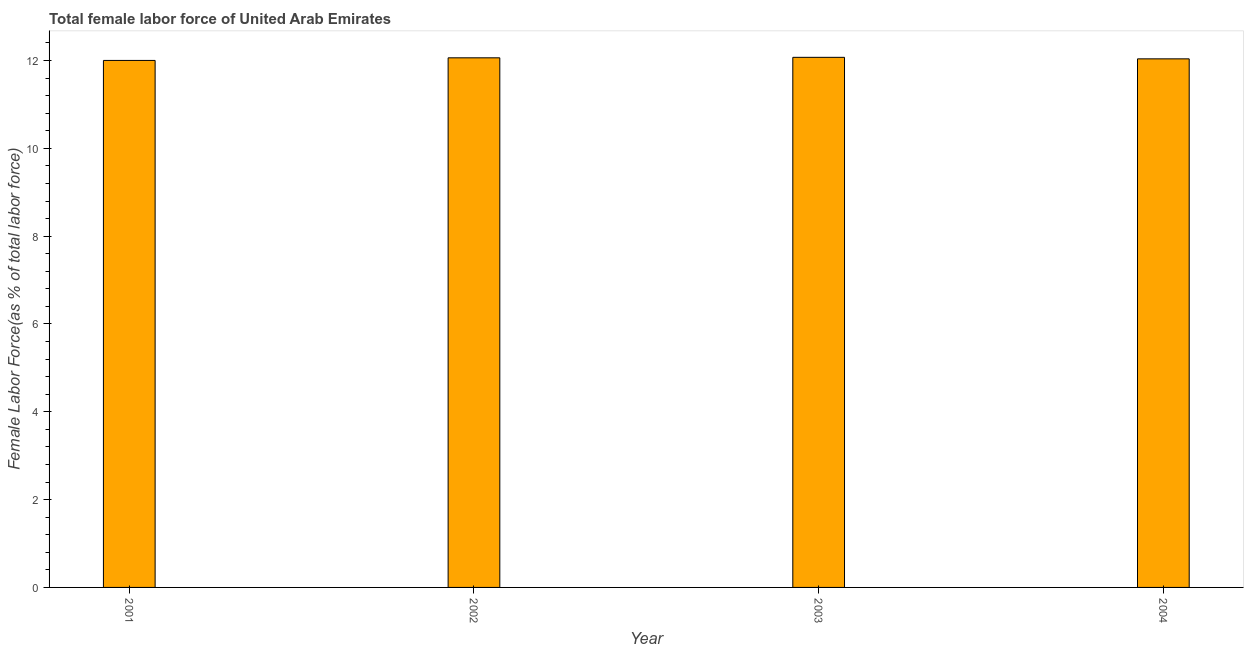What is the title of the graph?
Your response must be concise. Total female labor force of United Arab Emirates. What is the label or title of the Y-axis?
Your answer should be very brief. Female Labor Force(as % of total labor force). What is the total female labor force in 2003?
Make the answer very short. 12.07. Across all years, what is the maximum total female labor force?
Provide a succinct answer. 12.07. Across all years, what is the minimum total female labor force?
Ensure brevity in your answer.  12. In which year was the total female labor force maximum?
Give a very brief answer. 2003. What is the sum of the total female labor force?
Offer a very short reply. 48.18. What is the difference between the total female labor force in 2003 and 2004?
Keep it short and to the point. 0.04. What is the average total female labor force per year?
Offer a terse response. 12.04. What is the median total female labor force?
Provide a short and direct response. 12.05. Do a majority of the years between 2001 and 2004 (inclusive) have total female labor force greater than 8 %?
Offer a terse response. Yes. Is the difference between the total female labor force in 2001 and 2002 greater than the difference between any two years?
Your answer should be very brief. No. What is the difference between the highest and the second highest total female labor force?
Give a very brief answer. 0.01. What is the difference between the highest and the lowest total female labor force?
Provide a short and direct response. 0.07. In how many years, is the total female labor force greater than the average total female labor force taken over all years?
Provide a succinct answer. 2. Are all the bars in the graph horizontal?
Your answer should be compact. No. How many years are there in the graph?
Offer a very short reply. 4. Are the values on the major ticks of Y-axis written in scientific E-notation?
Provide a short and direct response. No. What is the Female Labor Force(as % of total labor force) of 2001?
Keep it short and to the point. 12. What is the Female Labor Force(as % of total labor force) in 2002?
Provide a short and direct response. 12.06. What is the Female Labor Force(as % of total labor force) in 2003?
Make the answer very short. 12.07. What is the Female Labor Force(as % of total labor force) in 2004?
Make the answer very short. 12.04. What is the difference between the Female Labor Force(as % of total labor force) in 2001 and 2002?
Your response must be concise. -0.06. What is the difference between the Female Labor Force(as % of total labor force) in 2001 and 2003?
Your answer should be compact. -0.07. What is the difference between the Female Labor Force(as % of total labor force) in 2001 and 2004?
Make the answer very short. -0.04. What is the difference between the Female Labor Force(as % of total labor force) in 2002 and 2003?
Ensure brevity in your answer.  -0.01. What is the difference between the Female Labor Force(as % of total labor force) in 2002 and 2004?
Ensure brevity in your answer.  0.02. What is the difference between the Female Labor Force(as % of total labor force) in 2003 and 2004?
Your answer should be very brief. 0.03. What is the ratio of the Female Labor Force(as % of total labor force) in 2001 to that in 2004?
Offer a terse response. 1. 